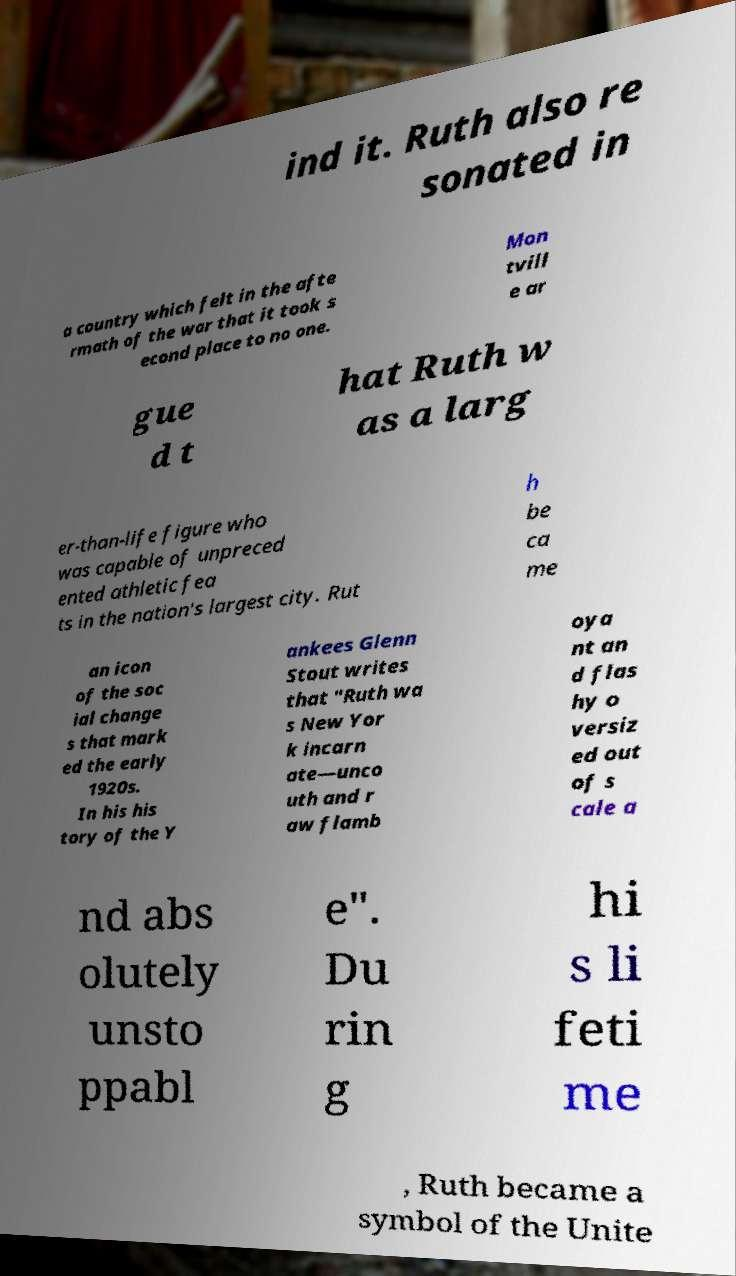Please read and relay the text visible in this image. What does it say? ind it. Ruth also re sonated in a country which felt in the afte rmath of the war that it took s econd place to no one. Mon tvill e ar gue d t hat Ruth w as a larg er-than-life figure who was capable of unpreced ented athletic fea ts in the nation's largest city. Rut h be ca me an icon of the soc ial change s that mark ed the early 1920s. In his his tory of the Y ankees Glenn Stout writes that "Ruth wa s New Yor k incarn ate—unco uth and r aw flamb oya nt an d flas hy o versiz ed out of s cale a nd abs olutely unsto ppabl e". Du rin g hi s li feti me , Ruth became a symbol of the Unite 